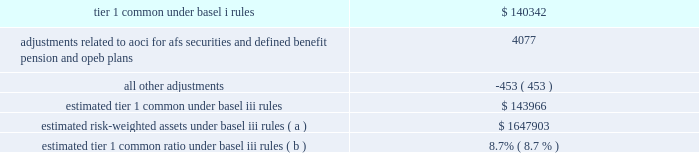Jpmorgan chase & co./2012 annual report 119 implementing further revisions to the capital accord in the u.s .
( such further revisions are commonly referred to as 201cbasel iii 201d ) .
Basel iii revised basel ii by , among other things , narrowing the definition of capital , and increasing capital requirements for specific exposures .
Basel iii also includes higher capital ratio requirements and provides that the tier 1 common capital requirement will be increased to 7% ( 7 % ) , comprised of a minimum ratio of 4.5% ( 4.5 % ) plus a 2.5% ( 2.5 % ) capital conservation buffer .
Implementation of the 7% ( 7 % ) tier 1 common capital requirement is required by january 1 , in addition , global systemically important banks ( 201cgsibs 201d ) will be required to maintain tier 1 common requirements above the 7% ( 7 % ) minimum in amounts ranging from an additional 1% ( 1 % ) to an additional 2.5% ( 2.5 % ) .
In november 2012 , the financial stability board ( 201cfsb 201d ) indicated that it would require the firm , as well as three other banks , to hold the additional 2.5% ( 2.5 % ) of tier 1 common ; the requirement will be phased in beginning in 2016 .
The basel committee also stated it intended to require certain gsibs to hold an additional 1% ( 1 % ) of tier 1 common under certain circumstances , to act as a disincentive for the gsib from taking actions that would further increase its systemic importance .
Currently , no gsib ( including the firm ) is required to hold this additional 1% ( 1 % ) of tier 1 common .
In addition , pursuant to the requirements of the dodd-frank act , u.s .
Federal banking agencies have proposed certain permanent basel i floors under basel ii and basel iii capital calculations .
The table presents a comparison of the firm 2019s tier 1 common under basel i rules to its estimated tier 1 common under basel iii rules , along with the firm 2019s estimated risk-weighted assets .
Tier 1 common under basel iii includes additional adjustments and deductions not included in basel i tier 1 common , such as the inclusion of aoci related to afs securities and defined benefit pension and other postretirement employee benefit ( 201copeb 201d ) plans .
The firm estimates that its tier 1 common ratio under basel iii rules would be 8.7% ( 8.7 % ) as of december 31 , 2012 .
The tier 1 common ratio under both basel i and basel iii are non- gaap financial measures .
However , such measures are used by bank regulators , investors and analysts as a key measure to assess the firm 2019s capital position and to compare the firm 2019s capital to that of other financial services companies .
December 31 , 2012 ( in millions , except ratios ) .
Estimated risk-weighted assets under basel iii rules ( a ) $ 1647903 estimated tier 1 common ratio under basel iii rules ( b ) 8.7% ( 8.7 % ) ( a ) key differences in the calculation of risk-weighted assets between basel i and basel iii include : ( 1 ) basel iii credit risk rwa is based on risk-sensitive approaches which largely rely on the use of internal credit models and parameters , whereas basel i rwa is based on fixed supervisory risk weightings which vary only by counterparty type and asset class ; ( 2 ) basel iii market risk rwa reflects the new capital requirements related to trading assets and securitizations , which include incremental capital requirements for stress var , correlation trading , and re-securitization positions ; and ( 3 ) basel iii includes rwa for operational risk , whereas basel i does not .
The actual impact on the firm 2019s capital ratios upon implementation could differ depending on final implementation guidance from the regulators , as well as regulatory approval of certain of the firm 2019s internal risk models .
( b ) the tier 1 common ratio is tier 1 common divided by rwa .
The firm 2019s estimate of its tier 1 common ratio under basel iii reflects its current understanding of the basel iii rules based on information currently published by the basel committee and u.s .
Federal banking agencies and on the application of such rules to its businesses as currently conducted ; it excludes the impact of any changes the firm may make in the future to its businesses as a result of implementing the basel iii rules , possible enhancements to certain market risk models , and any further implementation guidance from the regulators .
The basel iii capital requirements are subject to prolonged transition periods .
The transition period for banks to meet the tier 1 common requirement under basel iii was originally scheduled to begin in 2013 , with full implementation on january 1 , 2019 .
In november 2012 , the u.s .
Federal banking agencies announced a delay in the implementation dates for the basel iii capital requirements .
The additional capital requirements for gsibs will be phased in starting january 1 , 2016 , with full implementation on january 1 , 2019 .
Management 2019s current objective is for the firm to reach , by the end of 2013 , an estimated basel iii tier i common ratio of 9.5% ( 9.5 % ) .
Additional information regarding the firm 2019s capital ratios and the federal regulatory capital standards to which it is subject is presented in supervision and regulation on pages 1 20138 of the 2012 form 10-k , and note 28 on pages 306 2013 308 of this annual report .
Broker-dealer regulatory capital jpmorgan chase 2019s principal u.s .
Broker-dealer subsidiaries are j.p .
Morgan securities llc ( 201cjpmorgan securities 201d ) and j.p .
Morgan clearing corp .
( 201cjpmorgan clearing 201d ) .
Jpmorgan clearing is a subsidiary of jpmorgan securities and provides clearing and settlement services .
Jpmorgan securities and jpmorgan clearing are each subject to rule 15c3-1 under the securities exchange act of 1934 ( the 201cnet capital rule 201d ) .
Jpmorgan securities and jpmorgan clearing are also each registered as futures commission merchants and subject to rule 1.17 of the commodity futures trading commission ( 201ccftc 201d ) .
Jpmorgan securities and jpmorgan clearing have elected to compute their minimum net capital requirements in accordance with the 201calternative net capital requirements 201d of the net capital rule .
At december 31 , 2012 , jpmorgan securities 2019 net capital , as defined by the net capital rule , was $ 13.5 billion , exceeding the minimum requirement by .
How much more money would jp morgan need to meet management 2019s plan to reach an estimated basel iii tier i common ratio of 9.5%? 
Rationale: to find out how much money the firm would need we need to take the current estimated risk-weighted assets under basel iii rules and multiple it by 9.5% . we then take this number and subtract it from the current estimated tier 1 common under basel iii rules . this will get us our final answer of $ 12584
Computations: ((1647903 * 9.5%) - 143966)
Answer: 12584.785. 